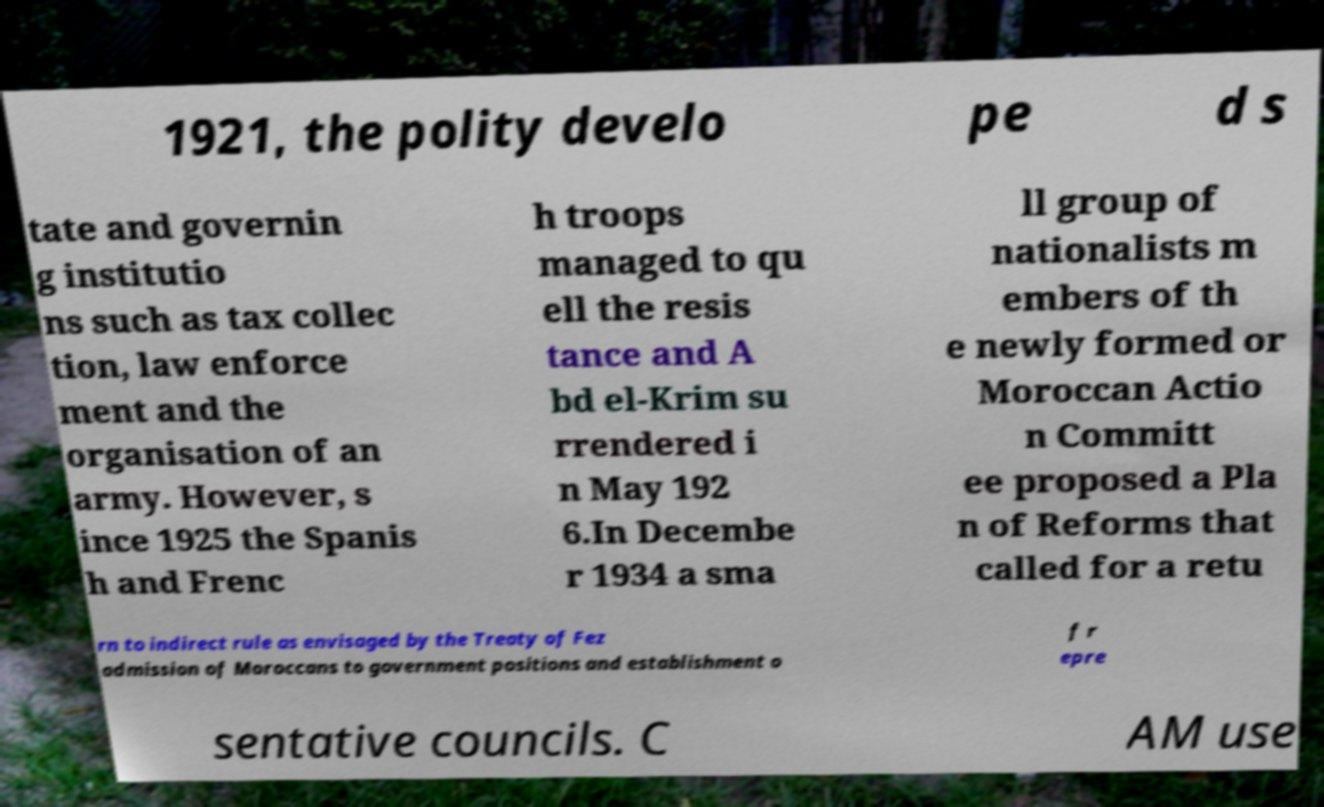Could you extract and type out the text from this image? 1921, the polity develo pe d s tate and governin g institutio ns such as tax collec tion, law enforce ment and the organisation of an army. However, s ince 1925 the Spanis h and Frenc h troops managed to qu ell the resis tance and A bd el-Krim su rrendered i n May 192 6.In Decembe r 1934 a sma ll group of nationalists m embers of th e newly formed or Moroccan Actio n Committ ee proposed a Pla n of Reforms that called for a retu rn to indirect rule as envisaged by the Treaty of Fez admission of Moroccans to government positions and establishment o f r epre sentative councils. C AM use 